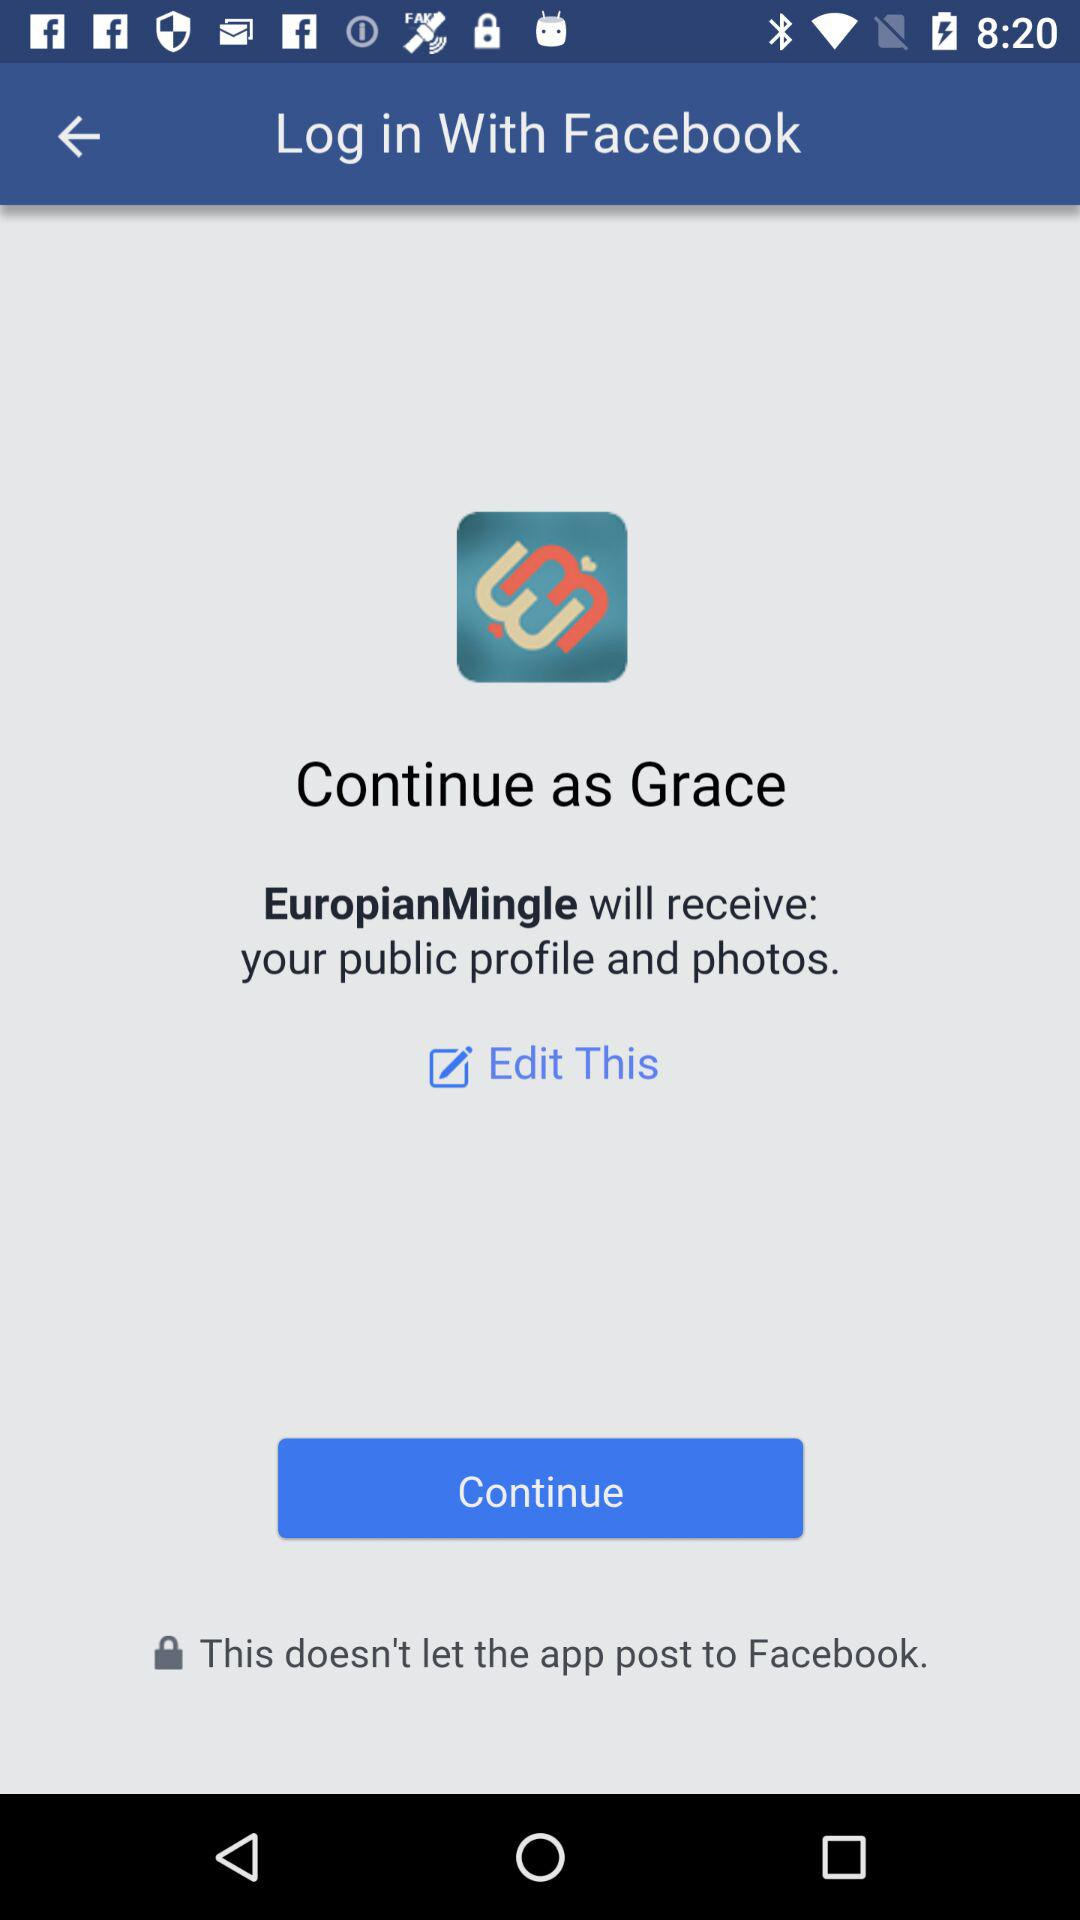What is the login name? The login name is Grace. 